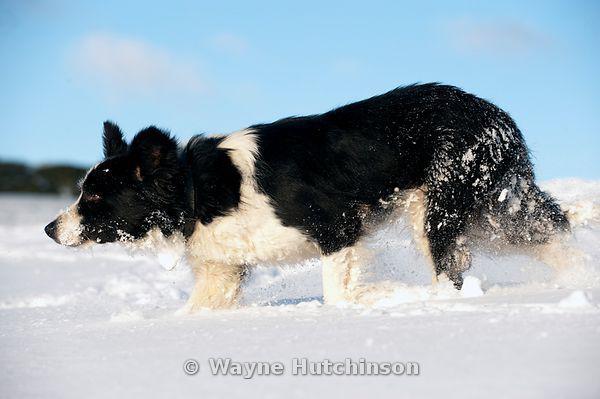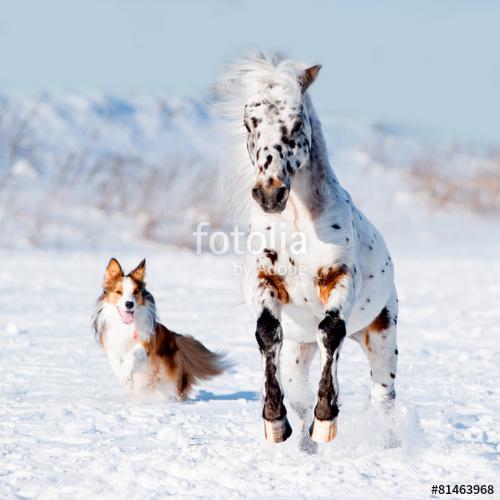The first image is the image on the left, the second image is the image on the right. Examine the images to the left and right. Is the description "There are visible paw prints in the snow in both images." accurate? Answer yes or no. Yes. The first image is the image on the left, the second image is the image on the right. Considering the images on both sides, is "There are no more than two dogs." valid? Answer yes or no. Yes. 